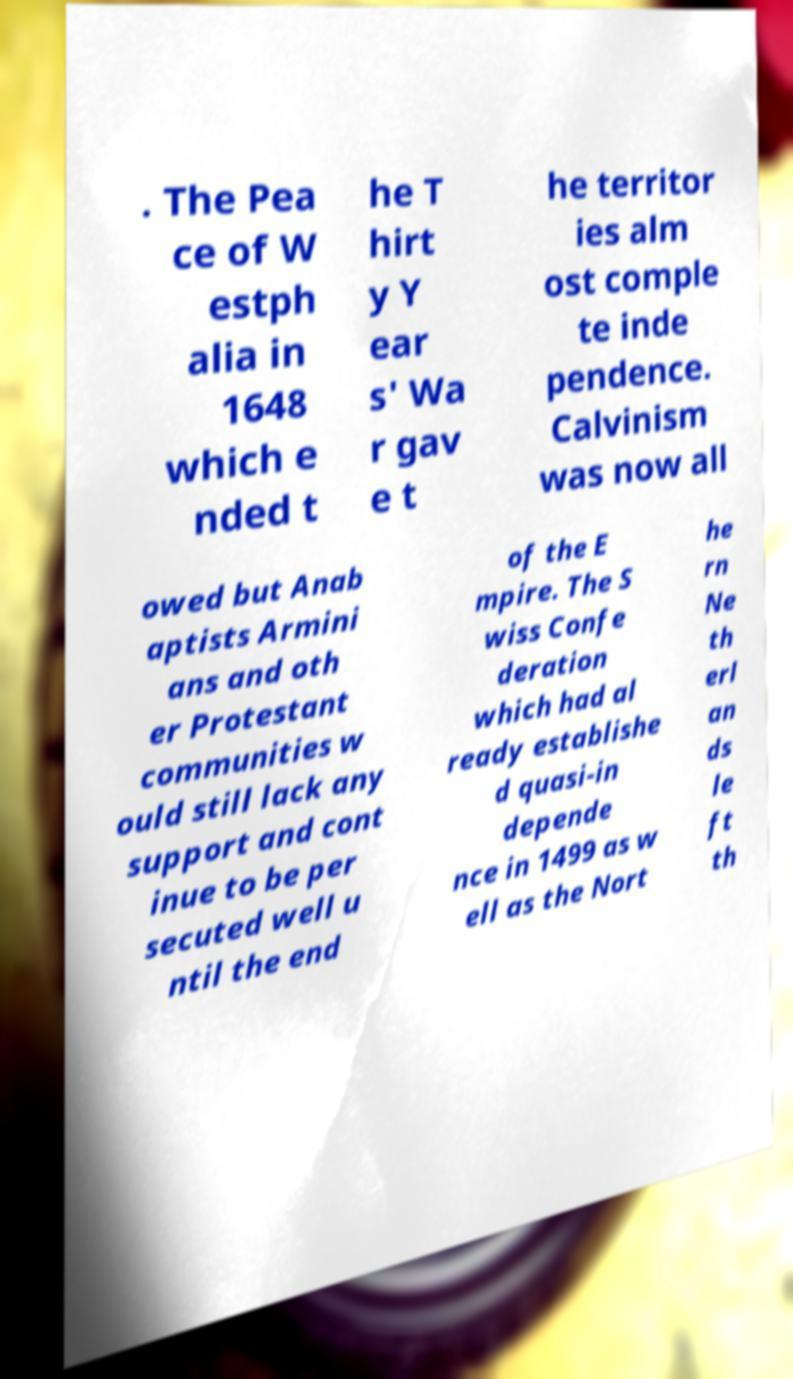Can you accurately transcribe the text from the provided image for me? . The Pea ce of W estph alia in 1648 which e nded t he T hirt y Y ear s' Wa r gav e t he territor ies alm ost comple te inde pendence. Calvinism was now all owed but Anab aptists Armini ans and oth er Protestant communities w ould still lack any support and cont inue to be per secuted well u ntil the end of the E mpire. The S wiss Confe deration which had al ready establishe d quasi-in depende nce in 1499 as w ell as the Nort he rn Ne th erl an ds le ft th 